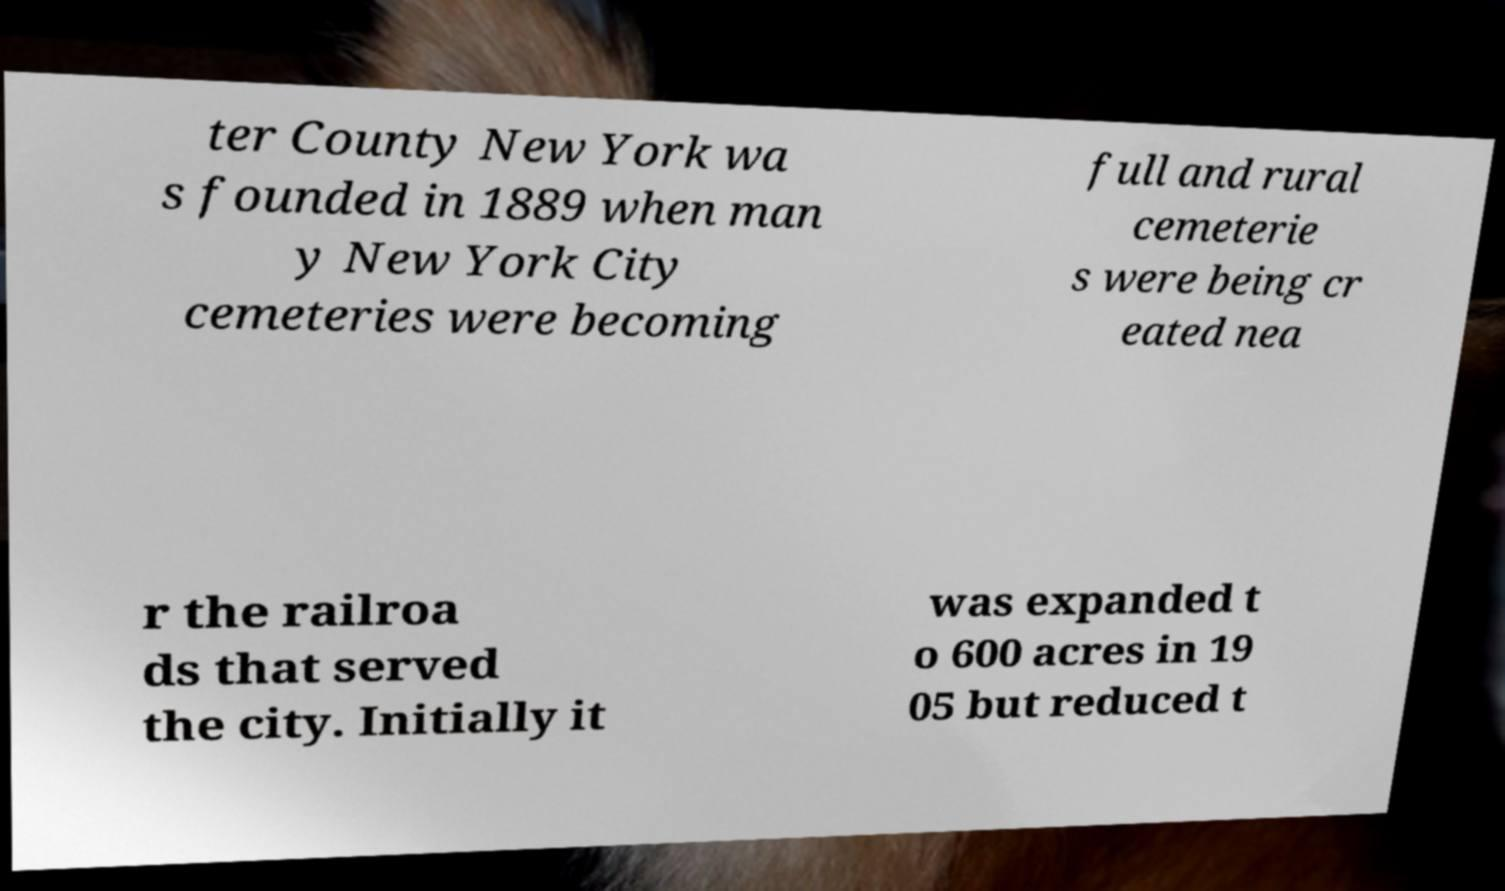What messages or text are displayed in this image? I need them in a readable, typed format. ter County New York wa s founded in 1889 when man y New York City cemeteries were becoming full and rural cemeterie s were being cr eated nea r the railroa ds that served the city. Initially it was expanded t o 600 acres in 19 05 but reduced t 